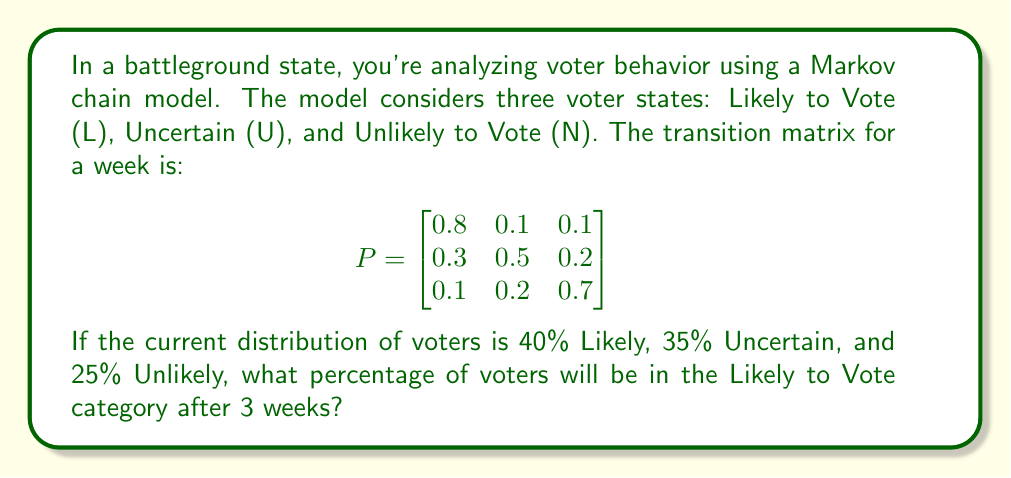Help me with this question. To solve this problem, we'll use the Markov chain model and matrix multiplication. Let's break it down step-by-step:

1) First, we need to represent the initial distribution as a row vector:

   $v_0 = \begin{bmatrix} 0.4 & 0.35 & 0.25 \end{bmatrix}$

2) To find the distribution after 3 weeks, we need to multiply this initial vector by the transition matrix P raised to the power of 3:

   $v_3 = v_0 \cdot P^3$

3) Let's calculate $P^3$:
   
   $P^2 = P \cdot P = \begin{bmatrix}
   0.67 & 0.18 & 0.15 \\
   0.41 & 0.37 & 0.22 \\
   0.22 & 0.25 & 0.53
   \end{bmatrix}$

   $P^3 = P^2 \cdot P = \begin{bmatrix}
   0.596 & 0.223 & 0.181 \\
   0.467 & 0.294 & 0.239 \\
   0.299 & 0.265 & 0.436
   \end{bmatrix}$

4) Now, we can multiply $v_0$ by $P^3$:

   $v_3 = \begin{bmatrix} 0.4 & 0.35 & 0.25 \end{bmatrix} \cdot \begin{bmatrix}
   0.596 & 0.223 & 0.181 \\
   0.467 & 0.294 & 0.239 \\
   0.299 & 0.265 & 0.436
   \end{bmatrix}$

5) Performing the matrix multiplication:

   $v_3 = \begin{bmatrix} 0.4(0.596) + 0.35(0.467) + 0.25(0.299) & ... & ... \end{bmatrix}$

6) Calculating the first element (which represents the Likely to Vote category):

   $0.4(0.596) + 0.35(0.467) + 0.25(0.299) = 0.2384 + 0.16345 + 0.07475 = 0.4766$

Therefore, after 3 weeks, approximately 47.66% of voters will be in the Likely to Vote category.
Answer: 47.66% 